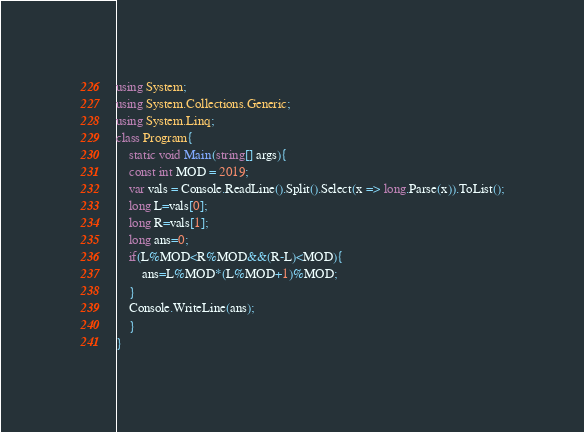Convert code to text. <code><loc_0><loc_0><loc_500><loc_500><_C#_>using System;
using System.Collections.Generic;
using System.Linq;
class Program{
    static void Main(string[] args){
    const int MOD = 2019;
    var vals = Console.ReadLine().Split().Select(x => long.Parse(x)).ToList();
    long L=vals[0];
    long R=vals[1];
    long ans=0;
    if(L%MOD<R%MOD&&(R-L)<MOD){
        ans=L%MOD*(L%MOD+1)%MOD;
    }
    Console.WriteLine(ans);
    }
}</code> 